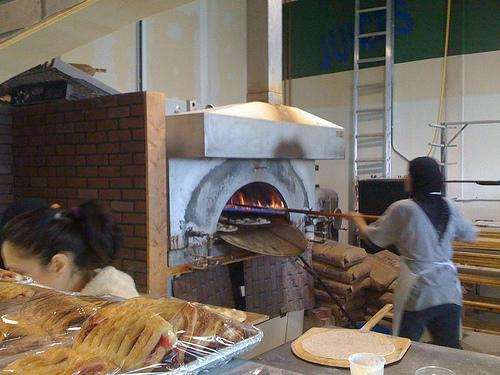What kind of oven is being used, and what's special about its design? A stone pizza oven with red brick design surrounding it is being used, giving it an authentic and rustic appearance. Name one specific type of pastry on the tray and the color of the countertop on the right side of the image. The specific type of pastry is a raspberry danish, and the countertop on the right side has a grey color. What kind of establishment is this image likely taking place in? This image is likely taking place in a bakery or a pizza restaurant with a brick oven. List three items observed in the image related to the process of baking. Pie dough on a tray, wooden baking paddle, and bags of flour in the background. Identify the main action performed by the woman in the image. A woman is putting a pizza in the oven using a wooden baking paddle. What type of baked goods are wrapped under plastic to stay fresh? Pastries, including raspberry danishes and berry-filled strudels, are wrapped under plastic to stay fresh. In a short sentence, describe the scene taking place near the oven in this image. A woman in a grey shirt and apron is placing a pizza in a stone oven with the aid of a wooden spatula. What is the primary purpose of the tall metal object on the right side of the image? The tall metal object, a ladder, is placed against the wall for assistance in reaching high places. What color is the woman's shirt and what is she doing? The woman is wearing a grey shirt and she is placing a pizza in the stone oven. Can you provide a description of how the woman in the image has styled her hair? The woman has black hair styled in a ponytail. 